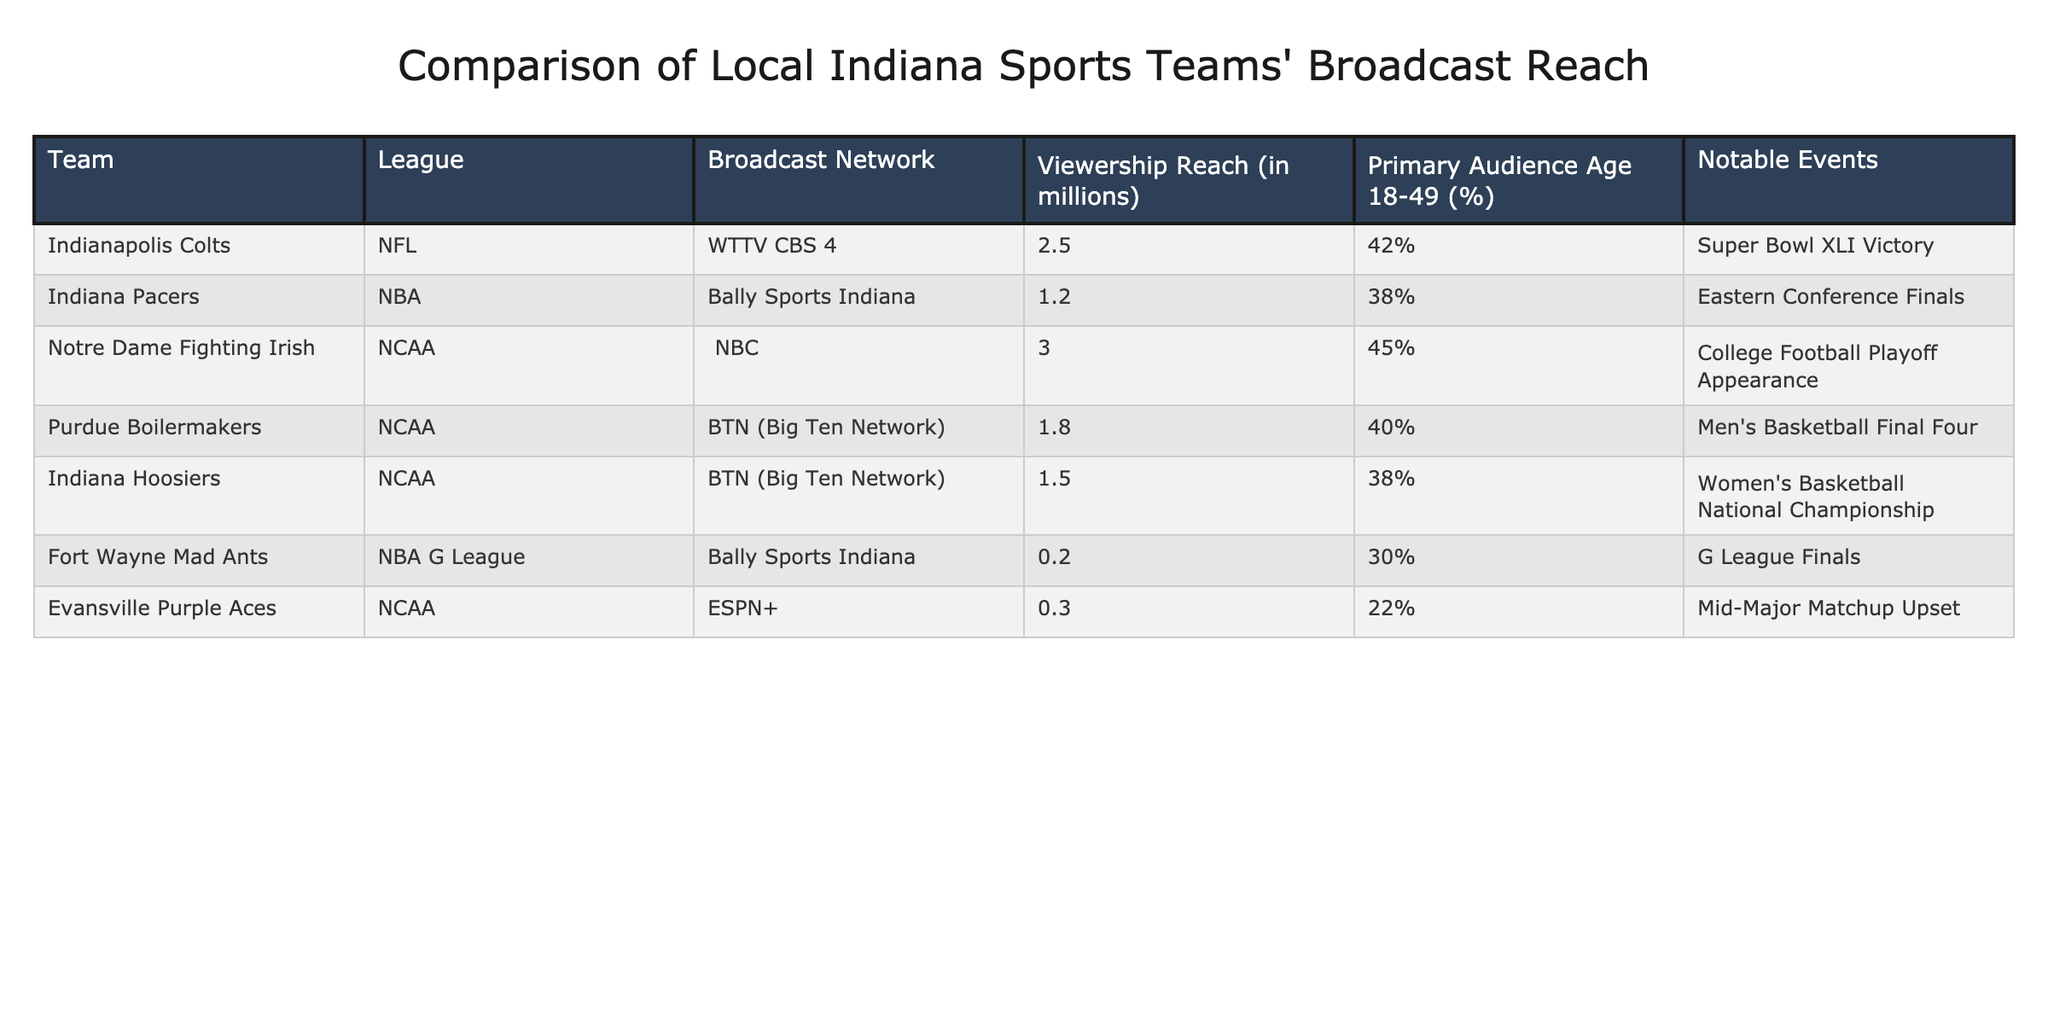What is the broadcast reach of the Notre Dame Fighting Irish? According to the table, the broadcast reach for the Notre Dame Fighting Irish is listed under the "Viewership Reach" column, which shows 3.0 million.
Answer: 3.0 million Which team has the highest percentage of audience aged 18-49? In the table, the percentages for the age group 18-49 are listed: Colts at 42%, Pacers at 38%, Notre Dame at 45%, Boilermakers at 40%, Hoosiers at 38%, Mad Ants at 30%, and Purple Aces at 22%. The highest percentage is 45%, for Notre Dame.
Answer: Notre Dame Fighting Irish How many teams have a viewership reach of over 1 million? By looking at the "Viewership Reach" column, the values over 1 million are: Notre Dame (3.0), Colts (2.5), Purdue (1.8), and Indiana (1.5), totaling four teams.
Answer: 4 teams Is the broadcast network for the Indiana Pacers also used by the Fort Wayne Mad Ants? The Indiana Pacers are broadcasted on Bally Sports Indiana, while the Fort Wayne Mad Ants are also on Bally Sports Indiana. This means they share the same broadcast network.
Answer: Yes What is the average viewership reach of teams in the NCAA league? The viewership reach for NCAA teams listed in the table are: Notre Dame (3.0), Purdue (1.8), Indiana (1.5), and Evansville (0.3). To find the average, sum these reaches: 3.0 + 1.8 + 1.5 + 0.3 = 6.6. There are four teams, so the average is 6.6 / 4 = 1.65.
Answer: 1.65 million Which team had a notable event related to a Super Bowl? The table lists the Indianapolis Colts with the notable event being "Super Bowl XLI Victory" under the "Notable Events" column.
Answer: Indianapolis Colts Do the Fort Wayne Mad Ants have a higher viewership reach than the Evansville Purple Aces? The table shows Fort Wayne Mad Ants with a viewership reach of 0.2 million and Evansville Purple Aces with 0.3 million. Since 0.2 is less than 0.3, the Fort Wayne Mad Ants do not have higher viewership reach.
Answer: No What is the difference in viewership reach between the Indianapolis Colts and the Indiana Hoosiers? The viewership reach for the Indianapolis Colts is 2.5 million while the Indiana Hoosiers have 1.5 million. The difference is 2.5 - 1.5 = 1.0 million.
Answer: 1.0 million 